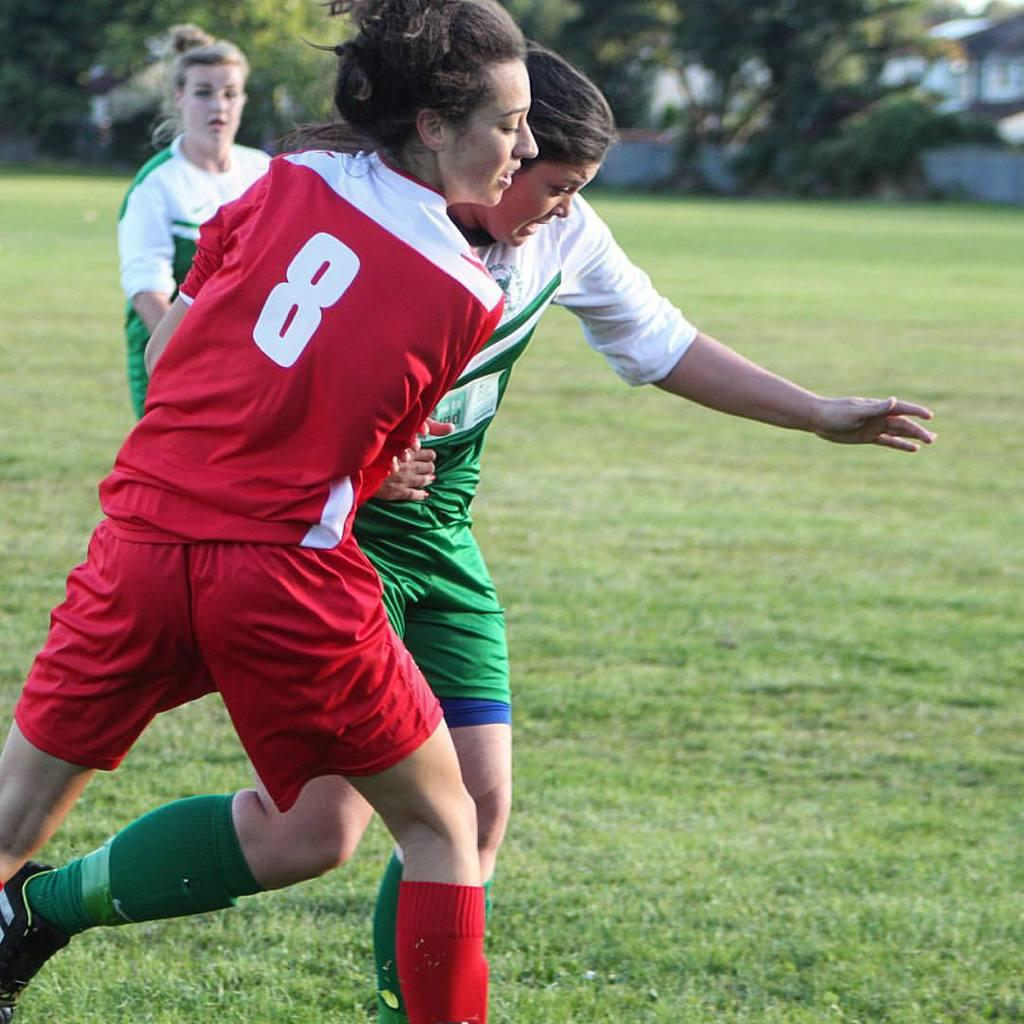<image>
Create a compact narrative representing the image presented. An athlete with a number 8 on the back of her uniform is on the field with two other athletes 